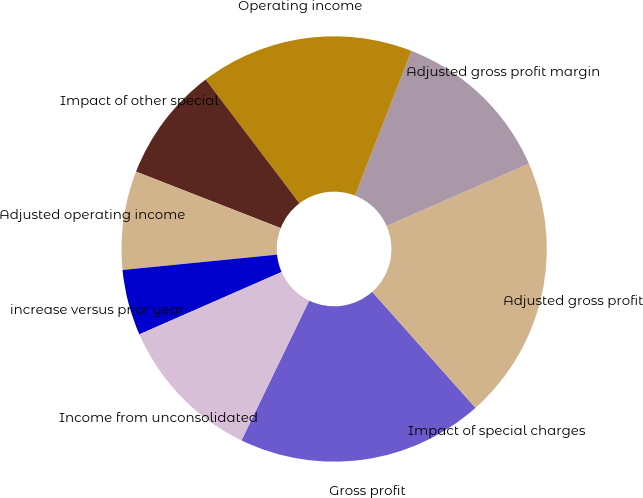Convert chart to OTSL. <chart><loc_0><loc_0><loc_500><loc_500><pie_chart><fcel>Gross profit<fcel>Impact of special charges<fcel>Adjusted gross profit<fcel>Adjusted gross profit margin<fcel>Operating income<fcel>Impact of other special<fcel>Adjusted operating income<fcel>increase versus prior year<fcel>Income from unconsolidated<nl><fcel>18.75%<fcel>0.0%<fcel>20.0%<fcel>12.5%<fcel>16.25%<fcel>8.75%<fcel>7.5%<fcel>5.0%<fcel>11.25%<nl></chart> 